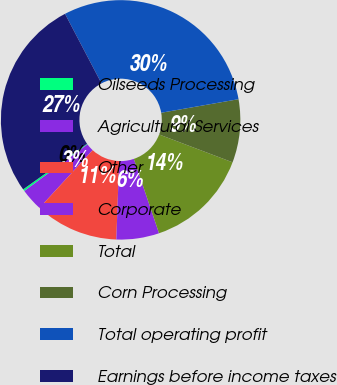Convert chart. <chart><loc_0><loc_0><loc_500><loc_500><pie_chart><fcel>Oilseeds Processing<fcel>Agricultural Services<fcel>Other<fcel>Corporate<fcel>Total<fcel>Corn Processing<fcel>Total operating profit<fcel>Earnings before income taxes<nl><fcel>0.27%<fcel>3.02%<fcel>11.28%<fcel>5.77%<fcel>14.03%<fcel>8.53%<fcel>29.92%<fcel>27.17%<nl></chart> 